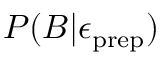Convert formula to latex. <formula><loc_0><loc_0><loc_500><loc_500>P ( B | \epsilon _ { p r e p } )</formula> 